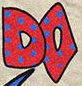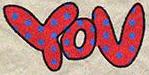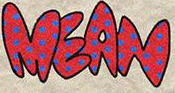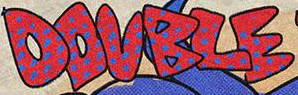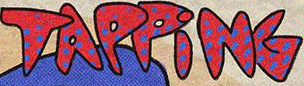Transcribe the words shown in these images in order, separated by a semicolon. DO; YOU; MEAN; DOUBLE; TAPPiNG 